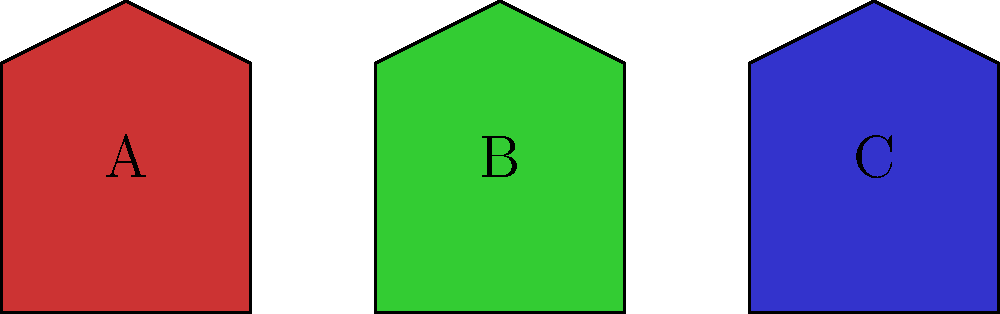Consider the three electric guitar shapes A, B, and C shown above. Which of these shapes has the highest order of rotational symmetry? To determine the order of rotational symmetry for each guitar shape, we need to identify how many distinct rotations (including the identity rotation) bring the shape back to its original position. Let's analyze each shape:

1. Shape A (Red guitar):
   - This shape has no rotational symmetry other than the identity rotation (360°).
   - Order of rotational symmetry: 1

2. Shape B (Green guitar):
   - This shape has rotational symmetry of order 2.
   - It can be rotated by 180° to return to its original position.
   - Order of rotational symmetry: 2

3. Shape C (Blue guitar):
   - This shape appears to have perfect left-right symmetry.
   - It can be rotated by 180° to return to its original position.
   - Order of rotational symmetry: 2

Comparing the orders of rotational symmetry:
- Shape A: 1
- Shape B: 2
- Shape C: 2

Therefore, shapes B and C have the highest order of rotational symmetry.
Answer: B and C (order 2) 